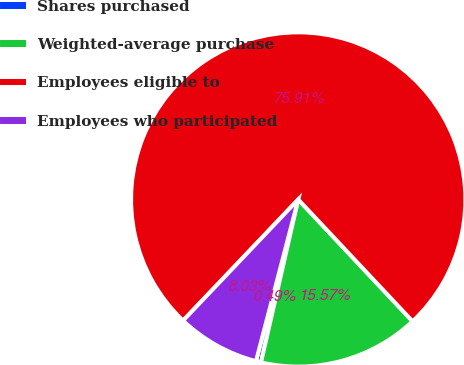Convert chart to OTSL. <chart><loc_0><loc_0><loc_500><loc_500><pie_chart><fcel>Shares purchased<fcel>Weighted-average purchase<fcel>Employees eligible to<fcel>Employees who participated<nl><fcel>0.49%<fcel>15.57%<fcel>75.9%<fcel>8.03%<nl></chart> 